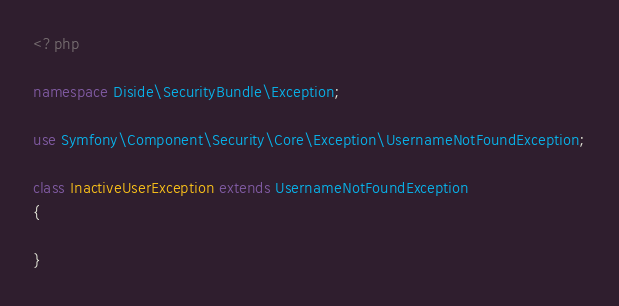Convert code to text. <code><loc_0><loc_0><loc_500><loc_500><_PHP_><?php

namespace Diside\SecurityBundle\Exception;

use Symfony\Component\Security\Core\Exception\UsernameNotFoundException;

class InactiveUserException extends UsernameNotFoundException
{

}</code> 